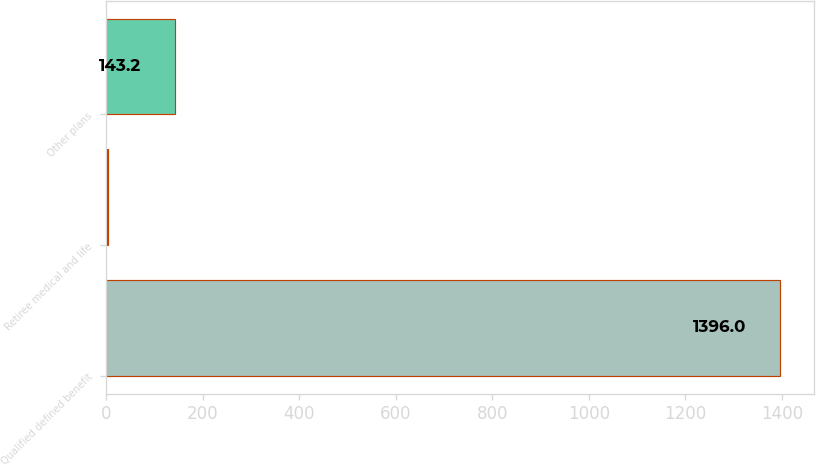<chart> <loc_0><loc_0><loc_500><loc_500><bar_chart><fcel>Qualified defined benefit<fcel>Retiree medical and life<fcel>Other plans<nl><fcel>1396<fcel>4<fcel>143.2<nl></chart> 